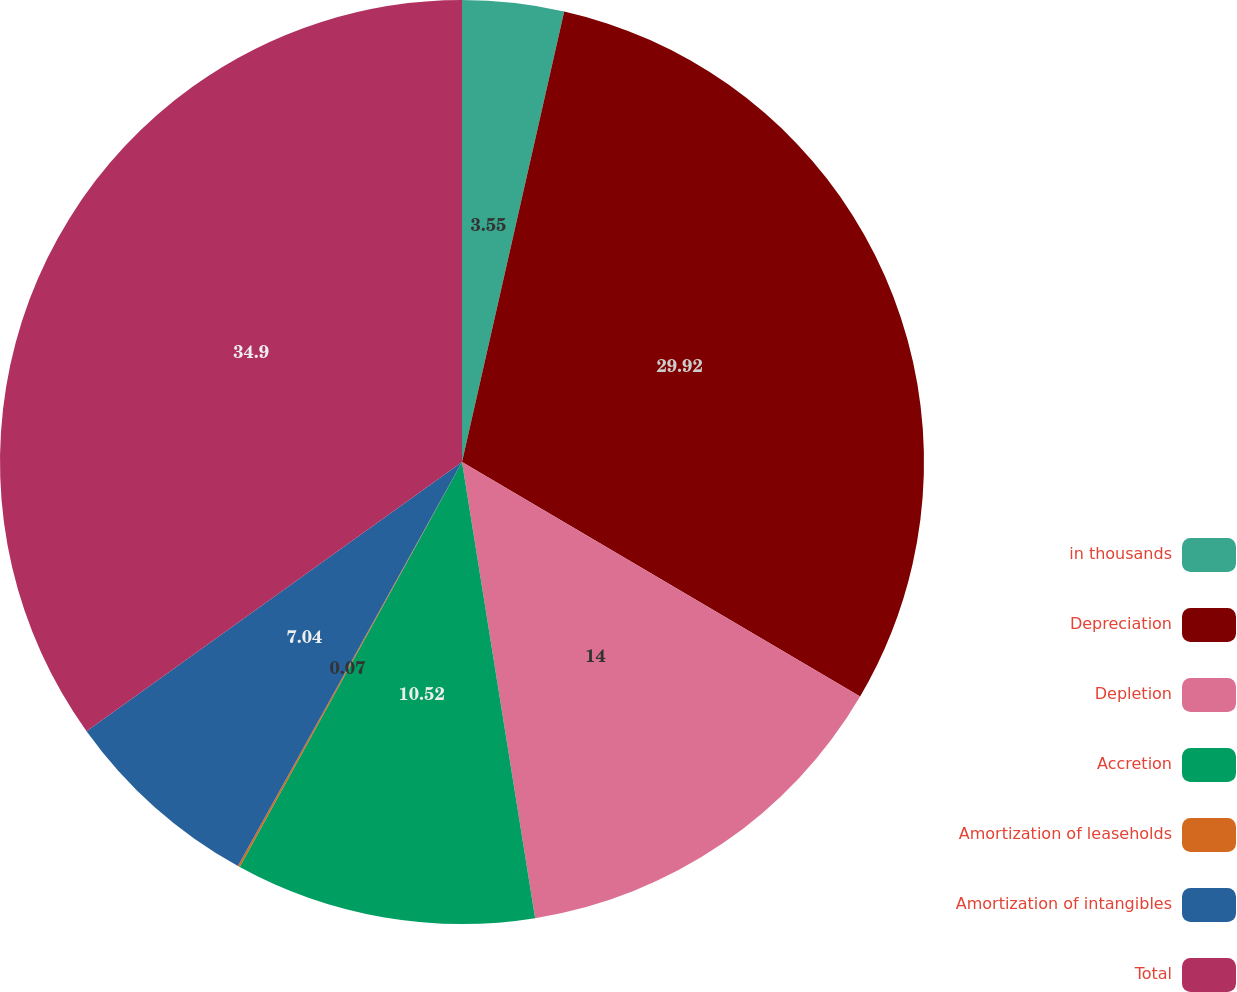<chart> <loc_0><loc_0><loc_500><loc_500><pie_chart><fcel>in thousands<fcel>Depreciation<fcel>Depletion<fcel>Accretion<fcel>Amortization of leaseholds<fcel>Amortization of intangibles<fcel>Total<nl><fcel>3.55%<fcel>29.92%<fcel>14.0%<fcel>10.52%<fcel>0.07%<fcel>7.04%<fcel>34.9%<nl></chart> 